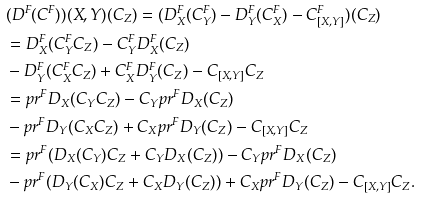Convert formula to latex. <formula><loc_0><loc_0><loc_500><loc_500>& ( D ^ { F } ( C ^ { F } ) ) ( X , Y ) ( C _ { Z } ) = ( D ^ { F } _ { X } ( C ^ { F } _ { Y } ) - D ^ { F } _ { Y } ( C ^ { F } _ { X } ) - C ^ { F } _ { [ X , Y ] } ) ( C _ { Z } ) \\ & = D ^ { F } _ { X } ( C ^ { F } _ { Y } C _ { Z } ) - C ^ { F } _ { Y } D ^ { F } _ { X } ( C _ { Z } ) \\ & - D ^ { F } _ { Y } ( C ^ { F } _ { X } C _ { Z } ) + C ^ { F } _ { X } D ^ { F } _ { Y } ( C _ { Z } ) - C _ { [ X , Y ] } C _ { Z } \\ & = p r ^ { F } D _ { X } ( C _ { Y } C _ { Z } ) - C _ { Y } p r ^ { F } D _ { X } ( C _ { Z } ) \\ & - p r ^ { F } D _ { Y } ( C _ { X } C _ { Z } ) + C _ { X } p r ^ { F } D _ { Y } ( C _ { Z } ) - C _ { [ X , Y ] } C _ { Z } \\ & = p r ^ { F } ( D _ { X } ( C _ { Y } ) C _ { Z } + C _ { Y } D _ { X } ( C _ { Z } ) ) - C _ { Y } p r ^ { F } D _ { X } ( C _ { Z } ) \\ & - p r ^ { F } ( D _ { Y } ( C _ { X } ) C _ { Z } + C _ { X } D _ { Y } ( C _ { Z } ) ) + C _ { X } p r ^ { F } D _ { Y } ( C _ { Z } ) - C _ { [ X , Y ] } C _ { Z } .</formula> 